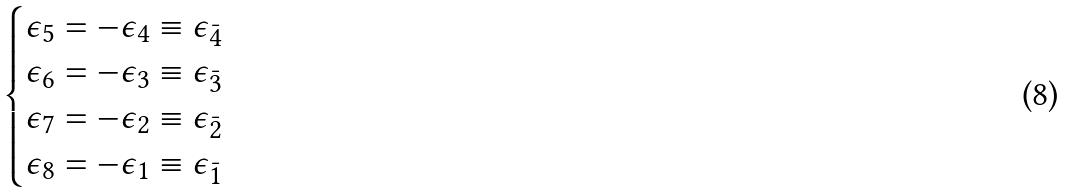<formula> <loc_0><loc_0><loc_500><loc_500>\begin{cases} \epsilon _ { 5 } = - \epsilon _ { 4 } \equiv \epsilon _ { \bar { 4 } } \\ \epsilon _ { 6 } = - \epsilon _ { 3 } \equiv \epsilon _ { \bar { 3 } } \\ \epsilon _ { 7 } = - \epsilon _ { 2 } \equiv \epsilon _ { \bar { 2 } } \\ \epsilon _ { 8 } = - \epsilon _ { 1 } \equiv \epsilon _ { \bar { 1 } } \end{cases}</formula> 